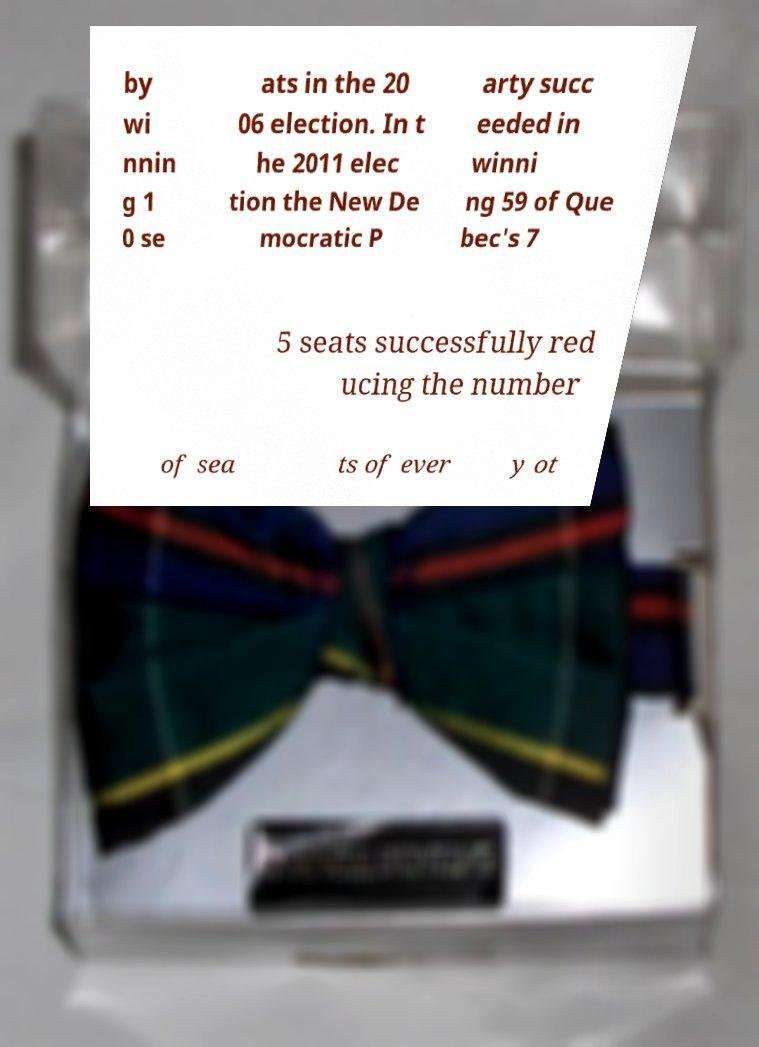I need the written content from this picture converted into text. Can you do that? by wi nnin g 1 0 se ats in the 20 06 election. In t he 2011 elec tion the New De mocratic P arty succ eeded in winni ng 59 of Que bec's 7 5 seats successfully red ucing the number of sea ts of ever y ot 